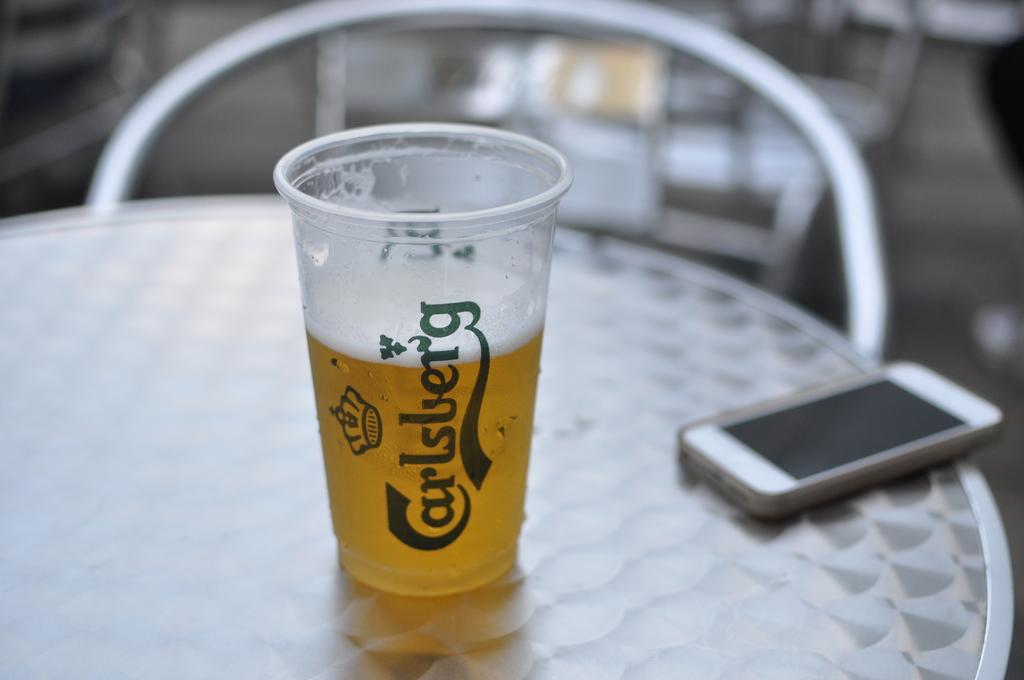What is printed on the glass?
Offer a terse response. Carlsberg. 